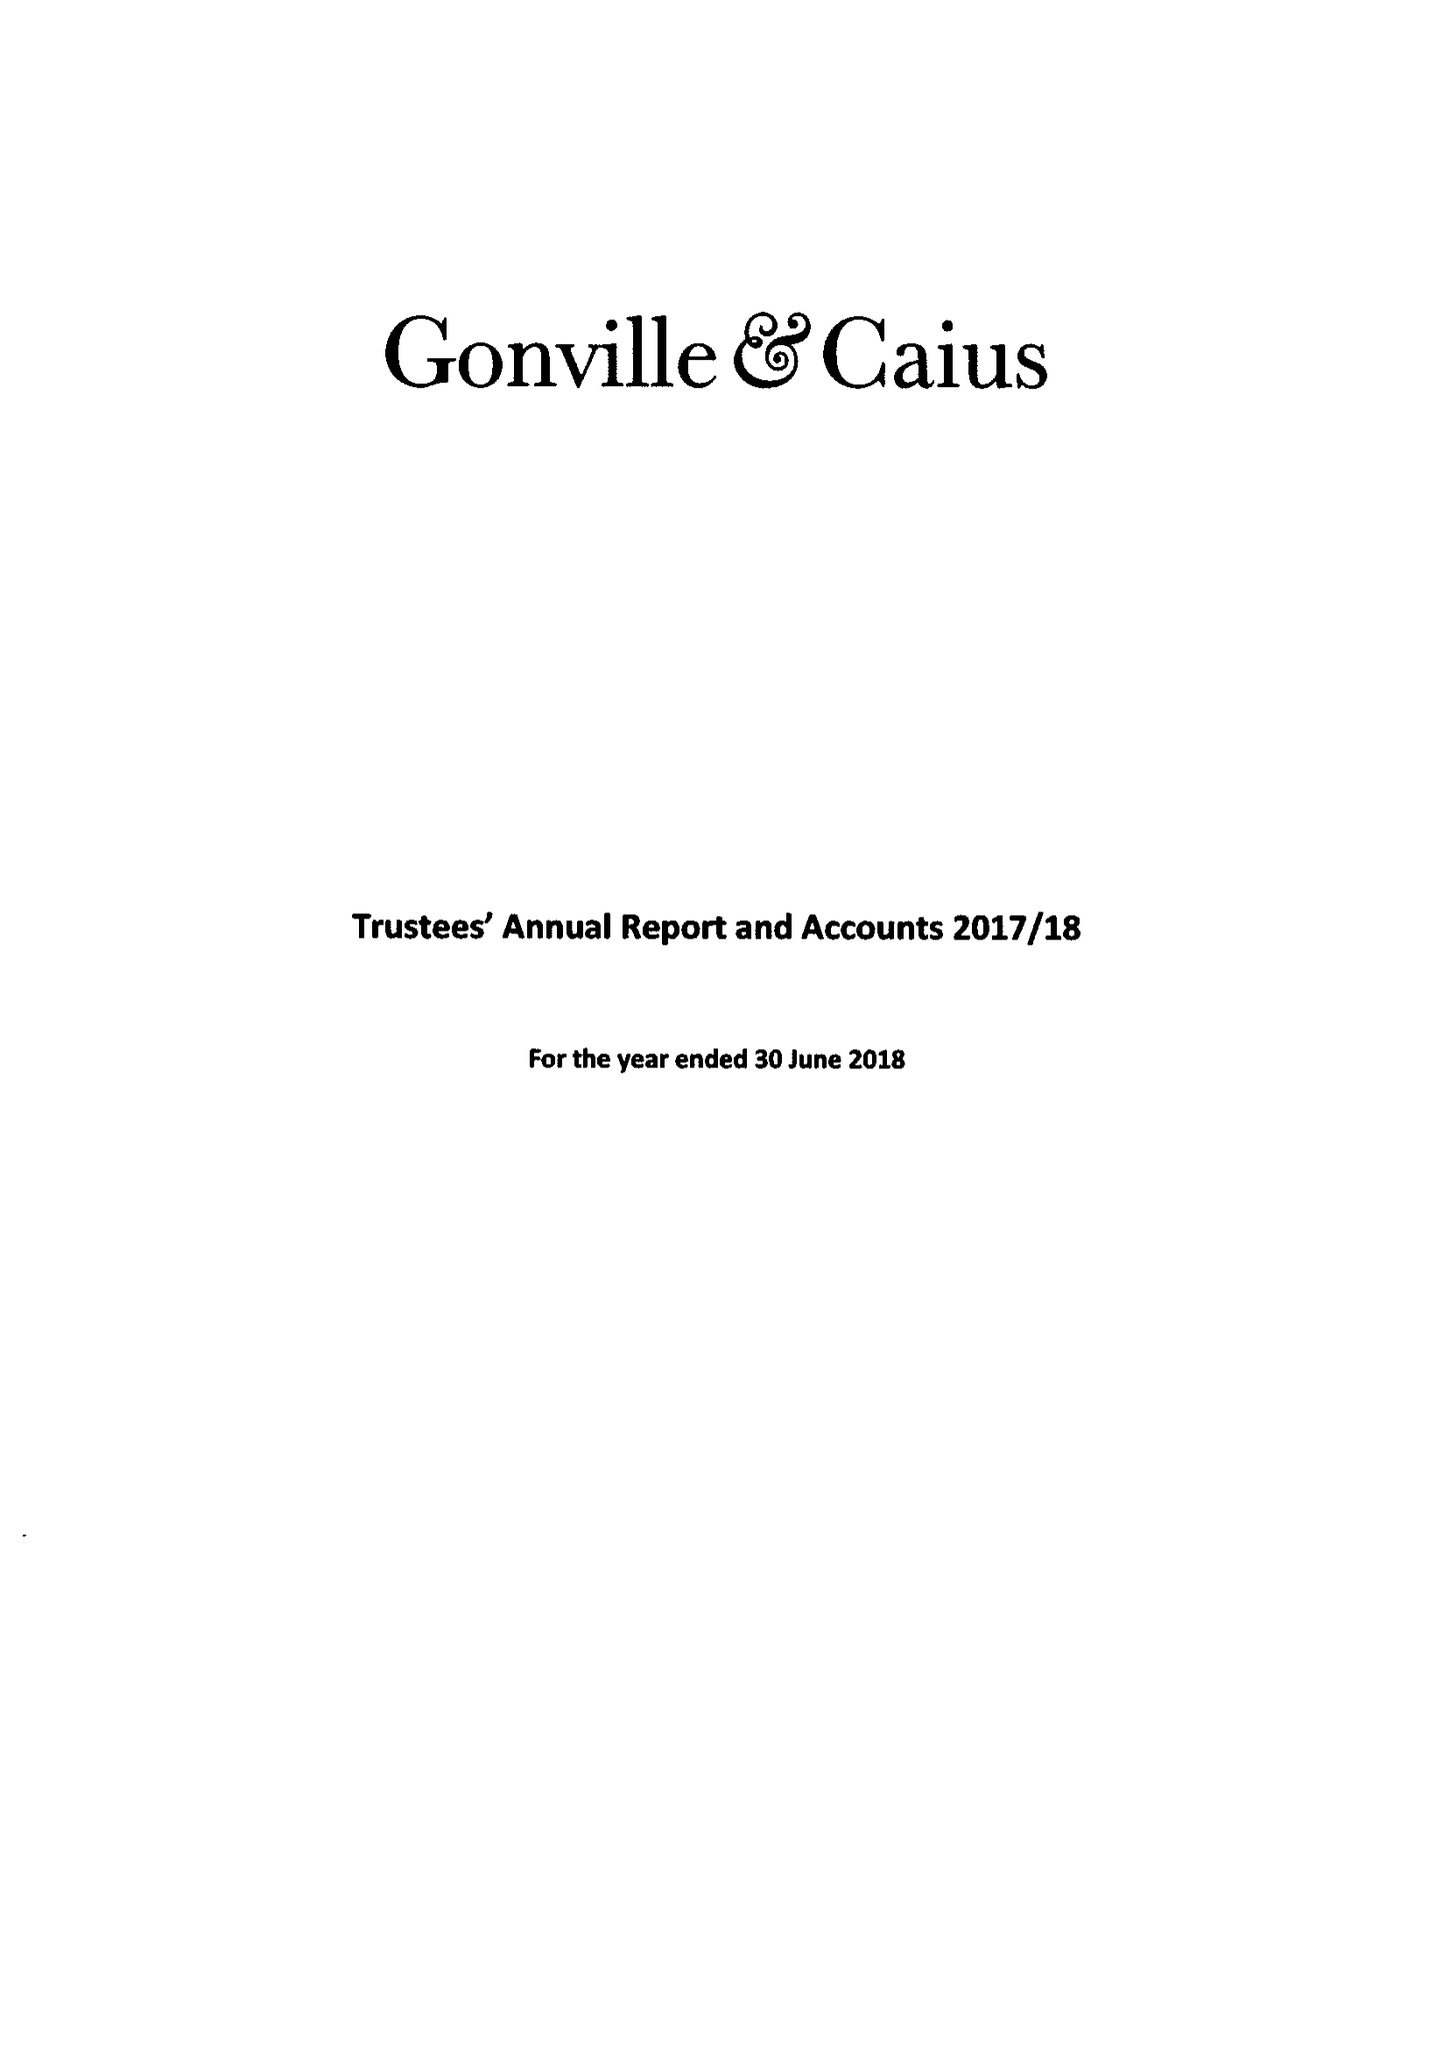What is the value for the charity_number?
Answer the question using a single word or phrase. 1137536 